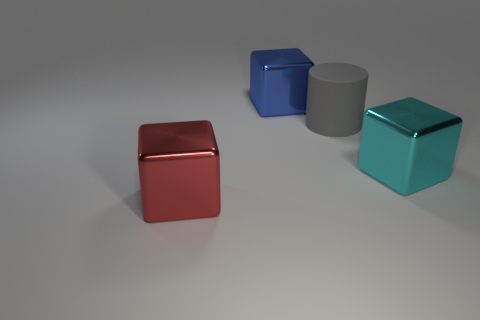Add 1 metallic blocks. How many objects exist? 5 Subtract all blocks. How many objects are left? 1 Add 3 big yellow rubber cylinders. How many big yellow rubber cylinders exist? 3 Subtract 1 blue blocks. How many objects are left? 3 Subtract all large cyan metallic blocks. Subtract all large red shiny things. How many objects are left? 2 Add 1 red metal blocks. How many red metal blocks are left? 2 